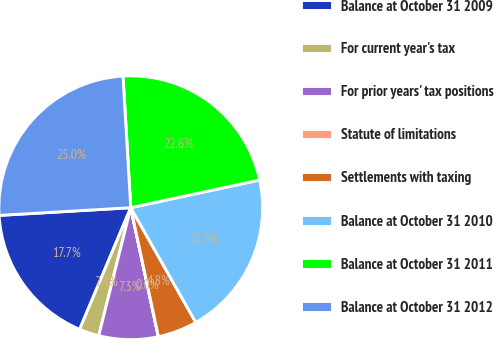Convert chart to OTSL. <chart><loc_0><loc_0><loc_500><loc_500><pie_chart><fcel>Balance at October 31 2009<fcel>For current year's tax<fcel>For prior years' tax positions<fcel>Statute of limitations<fcel>Settlements with taxing<fcel>Balance at October 31 2010<fcel>Balance at October 31 2011<fcel>Balance at October 31 2012<nl><fcel>17.74%<fcel>2.43%<fcel>7.26%<fcel>0.01%<fcel>4.84%<fcel>20.16%<fcel>22.57%<fcel>24.99%<nl></chart> 